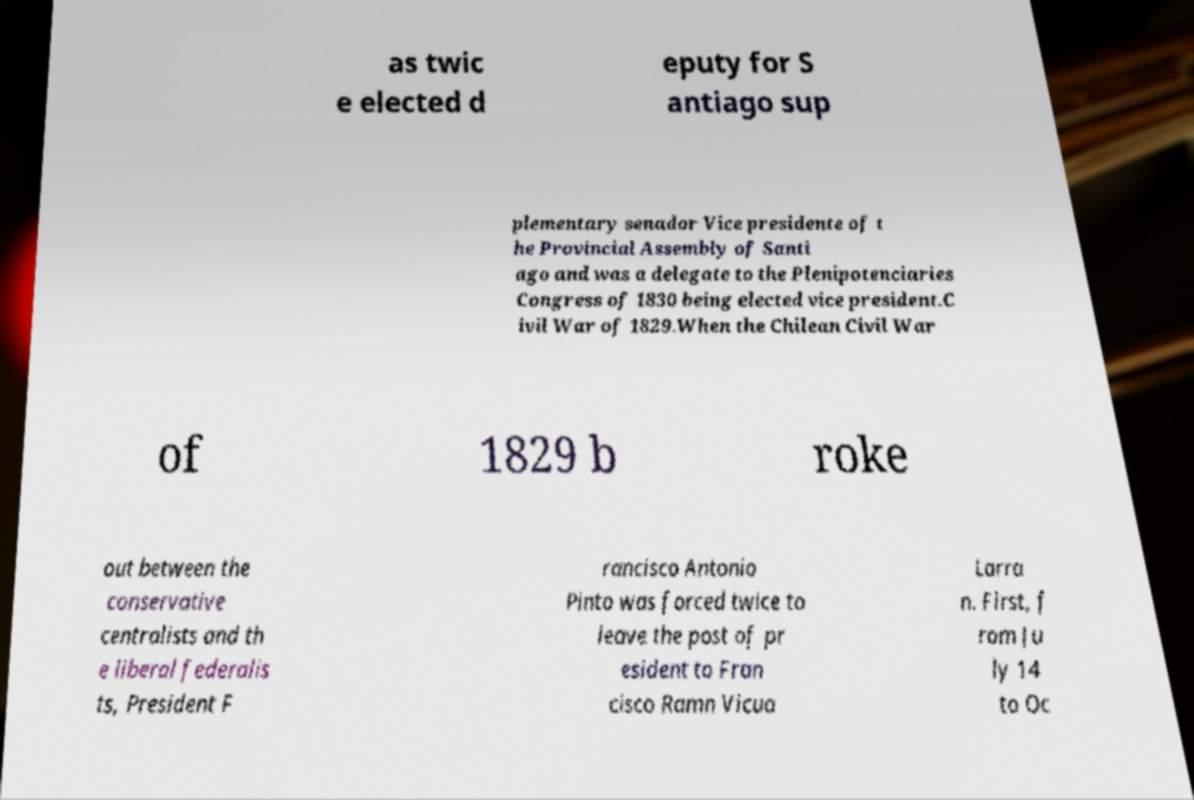I need the written content from this picture converted into text. Can you do that? as twic e elected d eputy for S antiago sup plementary senador Vice presidente of t he Provincial Assembly of Santi ago and was a delegate to the Plenipotenciaries Congress of 1830 being elected vice president.C ivil War of 1829.When the Chilean Civil War of 1829 b roke out between the conservative centralists and th e liberal federalis ts, President F rancisco Antonio Pinto was forced twice to leave the post of pr esident to Fran cisco Ramn Vicua Larra n. First, f rom Ju ly 14 to Oc 